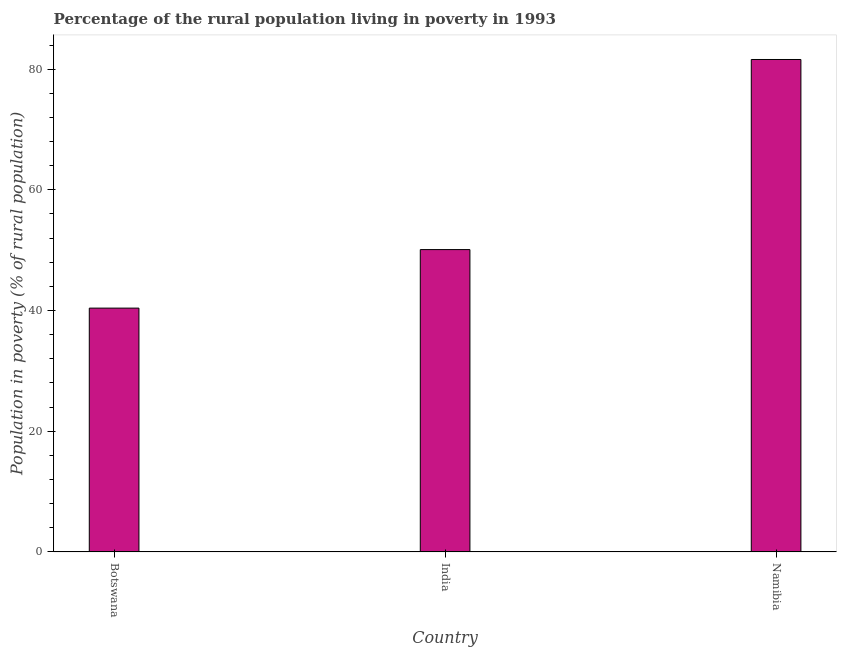Does the graph contain any zero values?
Make the answer very short. No. What is the title of the graph?
Keep it short and to the point. Percentage of the rural population living in poverty in 1993. What is the label or title of the Y-axis?
Make the answer very short. Population in poverty (% of rural population). What is the percentage of rural population living below poverty line in Botswana?
Give a very brief answer. 40.4. Across all countries, what is the maximum percentage of rural population living below poverty line?
Your answer should be compact. 81.6. Across all countries, what is the minimum percentage of rural population living below poverty line?
Keep it short and to the point. 40.4. In which country was the percentage of rural population living below poverty line maximum?
Provide a succinct answer. Namibia. In which country was the percentage of rural population living below poverty line minimum?
Your answer should be compact. Botswana. What is the sum of the percentage of rural population living below poverty line?
Provide a succinct answer. 172.1. What is the difference between the percentage of rural population living below poverty line in India and Namibia?
Provide a succinct answer. -31.5. What is the average percentage of rural population living below poverty line per country?
Give a very brief answer. 57.37. What is the median percentage of rural population living below poverty line?
Keep it short and to the point. 50.1. In how many countries, is the percentage of rural population living below poverty line greater than 72 %?
Provide a short and direct response. 1. What is the ratio of the percentage of rural population living below poverty line in Botswana to that in India?
Offer a very short reply. 0.81. Is the difference between the percentage of rural population living below poverty line in Botswana and Namibia greater than the difference between any two countries?
Give a very brief answer. Yes. What is the difference between the highest and the second highest percentage of rural population living below poverty line?
Your answer should be compact. 31.5. What is the difference between the highest and the lowest percentage of rural population living below poverty line?
Provide a short and direct response. 41.2. How many bars are there?
Your response must be concise. 3. Are all the bars in the graph horizontal?
Give a very brief answer. No. How many countries are there in the graph?
Your response must be concise. 3. What is the difference between two consecutive major ticks on the Y-axis?
Give a very brief answer. 20. Are the values on the major ticks of Y-axis written in scientific E-notation?
Provide a succinct answer. No. What is the Population in poverty (% of rural population) in Botswana?
Your answer should be compact. 40.4. What is the Population in poverty (% of rural population) in India?
Keep it short and to the point. 50.1. What is the Population in poverty (% of rural population) of Namibia?
Offer a terse response. 81.6. What is the difference between the Population in poverty (% of rural population) in Botswana and India?
Ensure brevity in your answer.  -9.7. What is the difference between the Population in poverty (% of rural population) in Botswana and Namibia?
Provide a succinct answer. -41.2. What is the difference between the Population in poverty (% of rural population) in India and Namibia?
Your answer should be very brief. -31.5. What is the ratio of the Population in poverty (% of rural population) in Botswana to that in India?
Ensure brevity in your answer.  0.81. What is the ratio of the Population in poverty (% of rural population) in Botswana to that in Namibia?
Provide a succinct answer. 0.49. What is the ratio of the Population in poverty (% of rural population) in India to that in Namibia?
Provide a short and direct response. 0.61. 